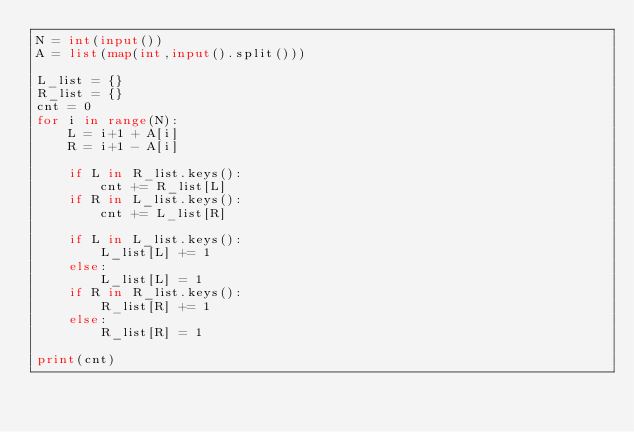<code> <loc_0><loc_0><loc_500><loc_500><_Python_>N = int(input())
A = list(map(int,input().split()))

L_list = {}
R_list = {}
cnt = 0
for i in range(N):
    L = i+1 + A[i]
    R = i+1 - A[i]

    if L in R_list.keys():
        cnt += R_list[L]
    if R in L_list.keys():
        cnt += L_list[R]

    if L in L_list.keys():
        L_list[L] += 1
    else:
        L_list[L] = 1
    if R in R_list.keys():
        R_list[R] += 1
    else:
        R_list[R] = 1

print(cnt)</code> 